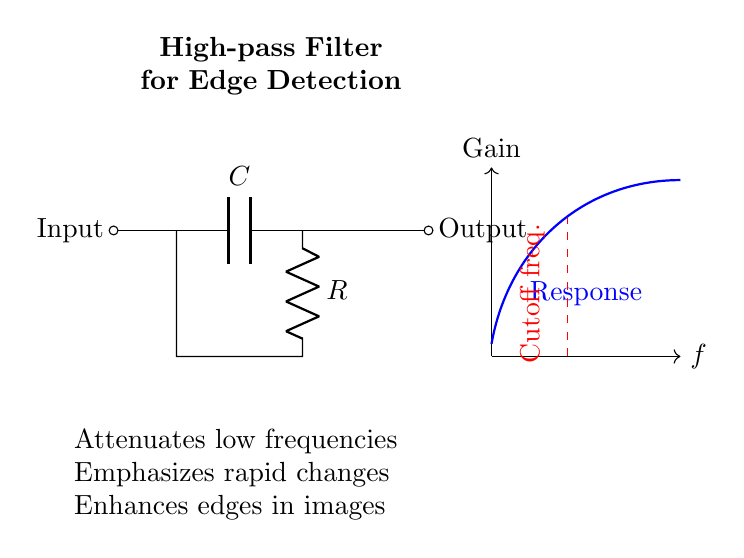What components are in this high-pass filter? The circuit diagram contains a capacitor and a resistor. The capacitor is labeled `C` and the resistor is labeled `R`.
Answer: Capacitor and resistor What is the function of the capacitor in this high-pass filter? The capacitor in a high-pass filter blocks low-frequency signals while allowing high-frequency signals to pass through. It reacts to the change in voltage, affecting the overall frequency response of the circuit.
Answer: Blocks low frequencies What is the expected frequency response shape of this high-pass filter? The frequency response of a high-pass filter typically rises above the cutoff frequency and shows a significant gain for higher frequencies. In the diagram, the gain rises as frequency increases after the marked cutoff frequency.
Answer: Rising gain above cutoff frequency What happens to the gain when the frequency is below the cutoff frequency? Below the cutoff frequency, the circuit significantly attenuates the signals, meaning they are reduced in amplitude, ultimately resulting in low gain values. The diagram shows that the gain drops to low levels in this range.
Answer: Attenuates signals Where is the cutoff frequency indicated in the diagram? The cutoff frequency is marked by a dashed red line at a specific frequency point along the x-axis, indicating the boundary between low and high frequencies for signal processing.
Answer: Dashed red line How does this high-pass filter enhance edges in image processing applications? By allowing high-frequency components that correspond to rapid changes in pixel intensity, such as edges, to pass through while filtering out lower frequency information. This enhances the visibility of edges in images.
Answer: Enhances rapid changes What type of application might benefit from this high-pass filter? High-pass filters are particularly useful in edge detection algorithms in computer vision applications, where the focus is on emphasizing sharp transitions in pixel values, making them crucial for image analysis.
Answer: Edge detection in computer vision 